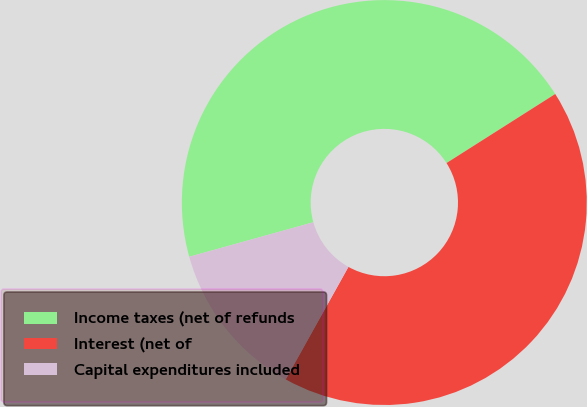Convert chart. <chart><loc_0><loc_0><loc_500><loc_500><pie_chart><fcel>Income taxes (net of refunds<fcel>Interest (net of<fcel>Capital expenditures included<nl><fcel>45.31%<fcel>42.1%<fcel>12.59%<nl></chart> 